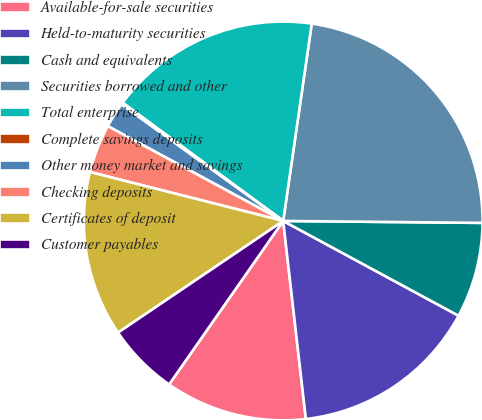Convert chart. <chart><loc_0><loc_0><loc_500><loc_500><pie_chart><fcel>Available-for-sale securities<fcel>Held-to-maturity securities<fcel>Cash and equivalents<fcel>Securities borrowed and other<fcel>Total enterprise<fcel>Complete savings deposits<fcel>Other money market and savings<fcel>Checking deposits<fcel>Certificates of deposit<fcel>Customer payables<nl><fcel>11.51%<fcel>15.3%<fcel>7.73%<fcel>22.87%<fcel>17.19%<fcel>0.16%<fcel>2.05%<fcel>3.94%<fcel>13.41%<fcel>5.84%<nl></chart> 